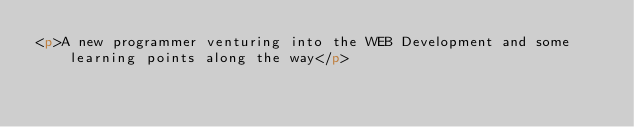<code> <loc_0><loc_0><loc_500><loc_500><_HTML_><p>A new programmer venturing into the WEB Development and some learning points along the way</p>
</code> 